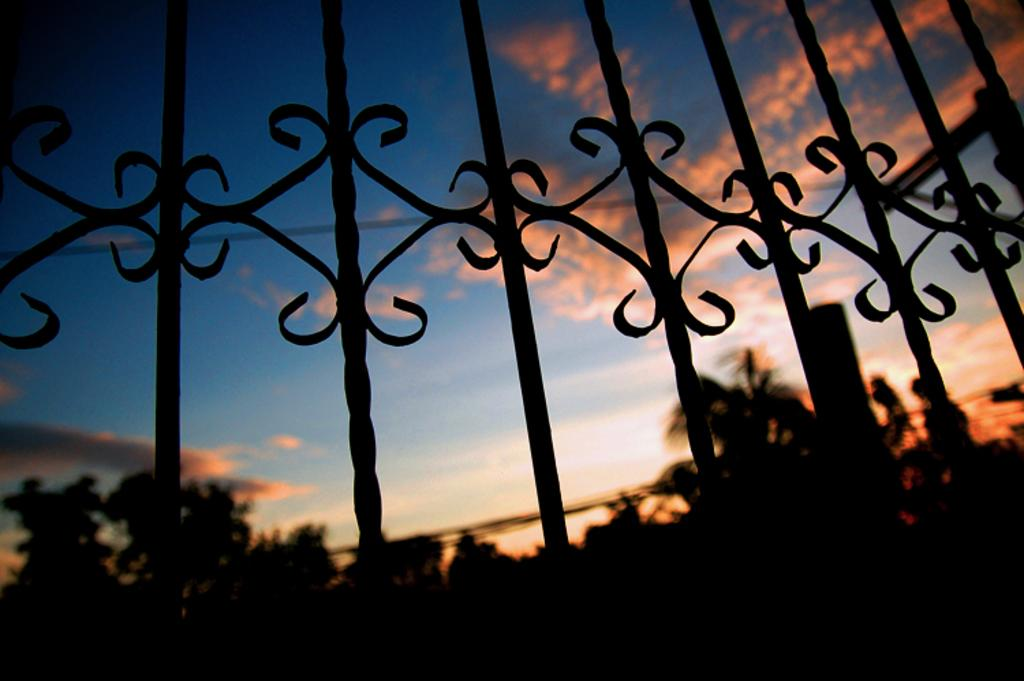What structure can be seen in the image? There is a gate in the image. What is located behind the gate? Trees are visible behind the gate. How would you describe the sky in the image? The sky is cloudy in the image. What type of lamp is being used to measure the height of the trees in the image? There is no lamp or measurement of tree height present in the image. 